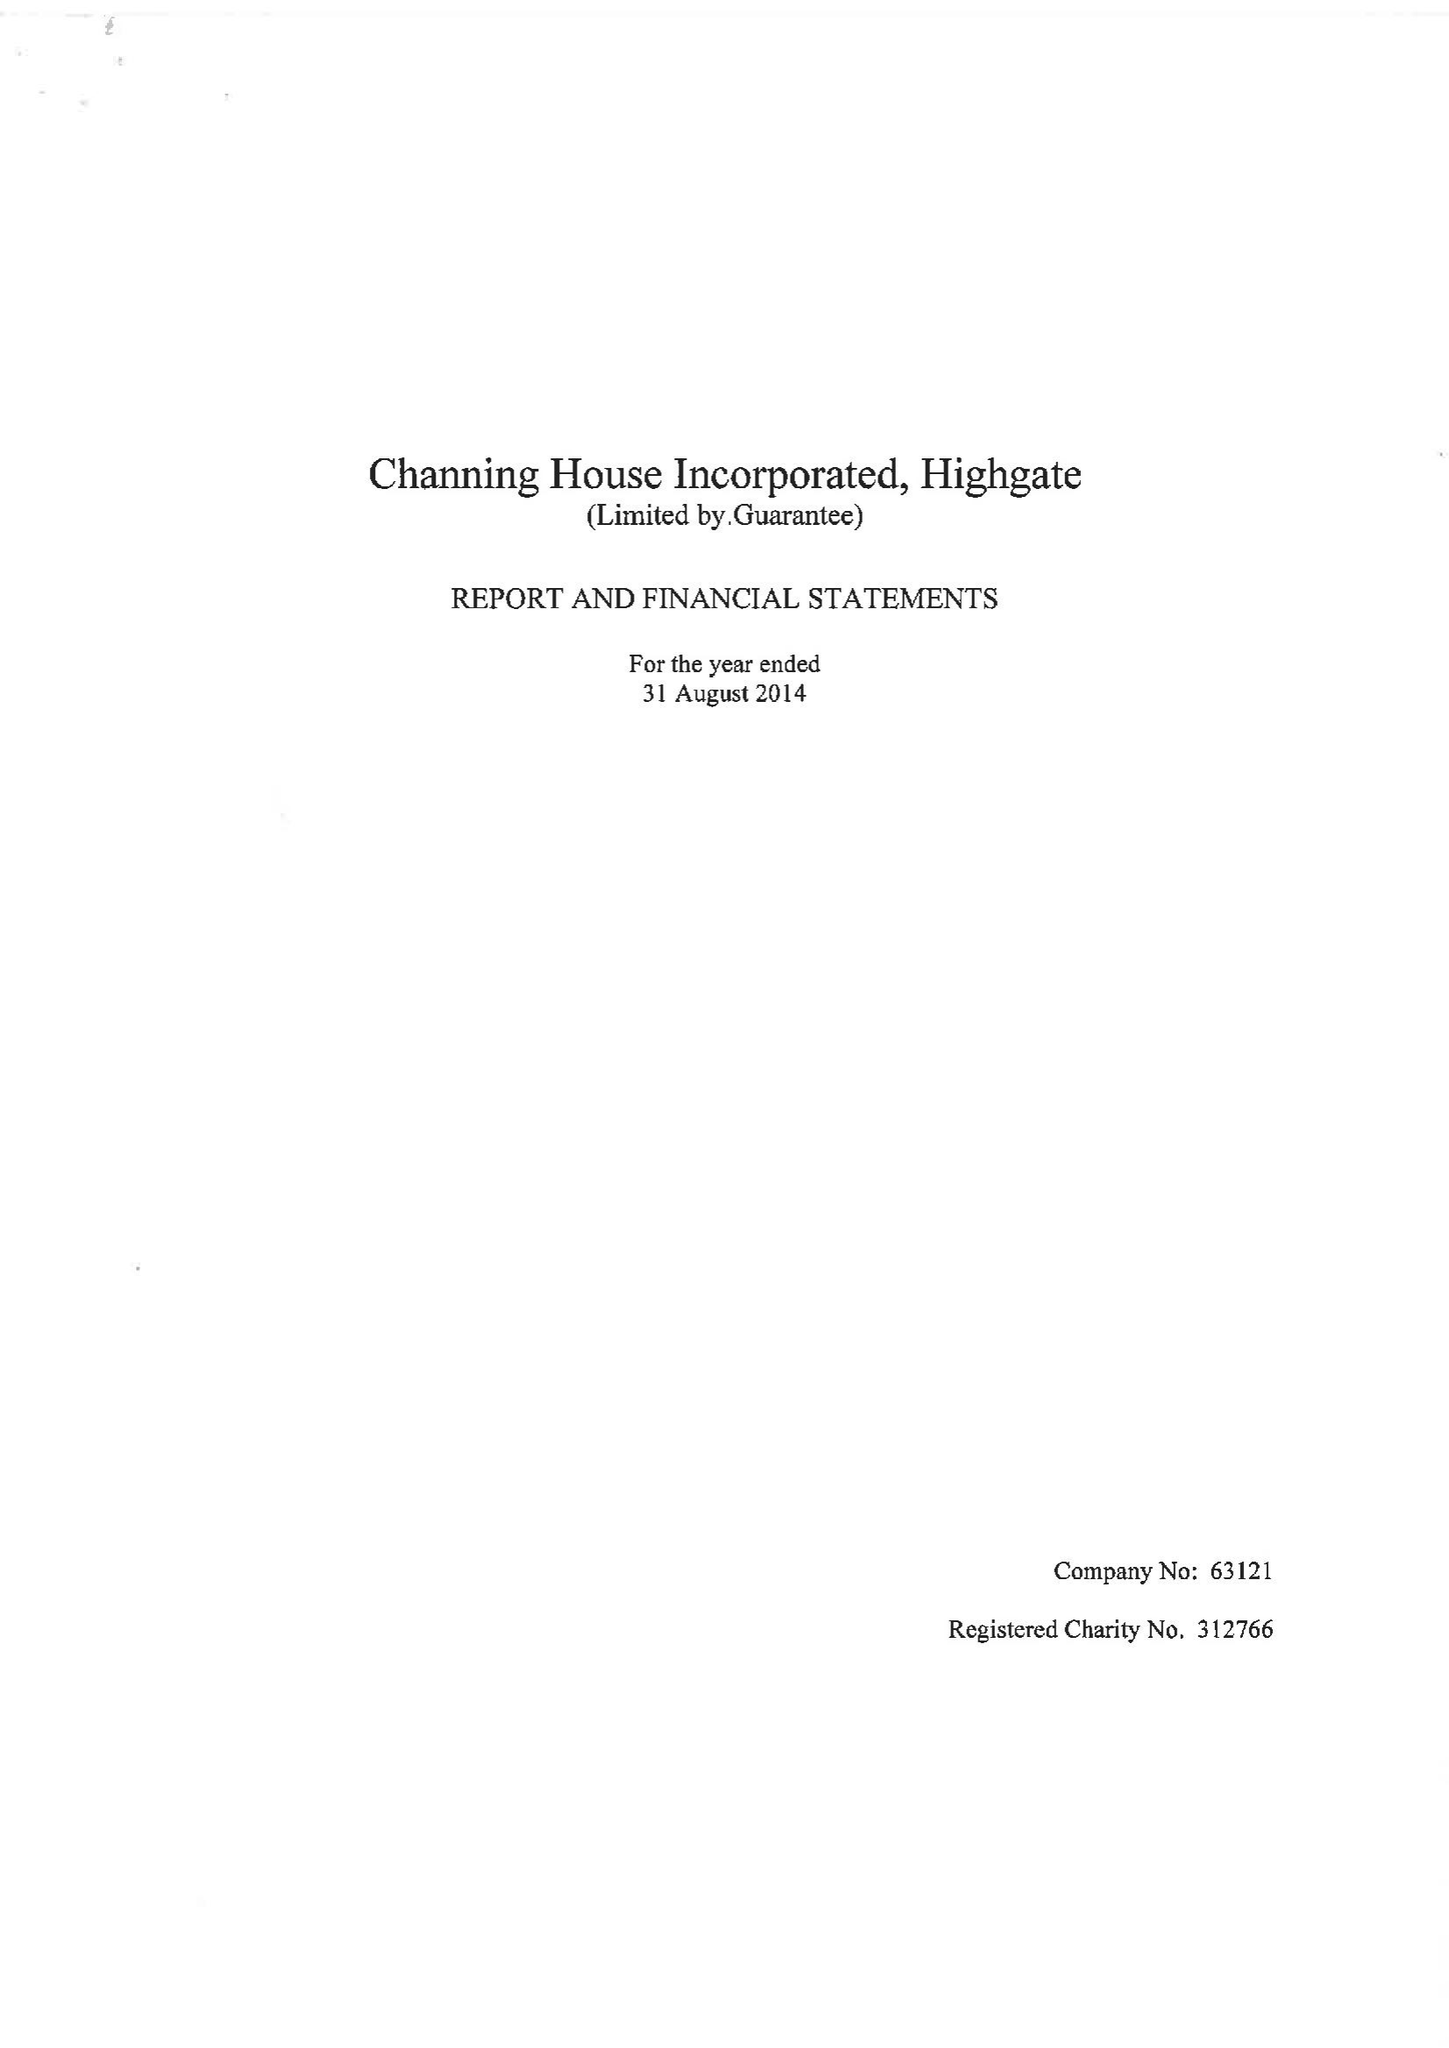What is the value for the address__street_line?
Answer the question using a single word or phrase. HIGHGATE HILL 